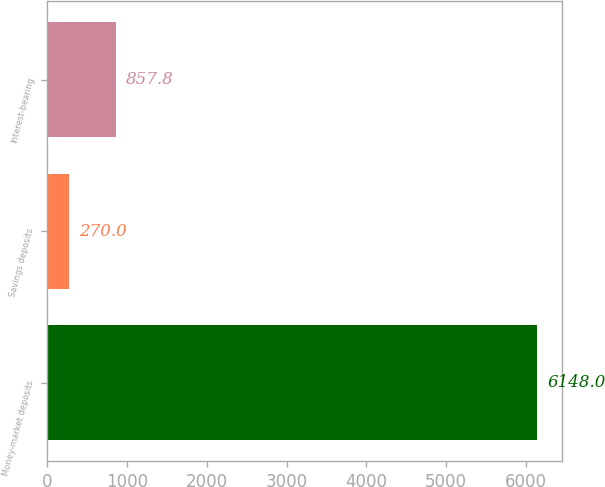Convert chart to OTSL. <chart><loc_0><loc_0><loc_500><loc_500><bar_chart><fcel>Money-market deposits<fcel>Savings deposits<fcel>Interest-bearing<nl><fcel>6148<fcel>270<fcel>857.8<nl></chart> 